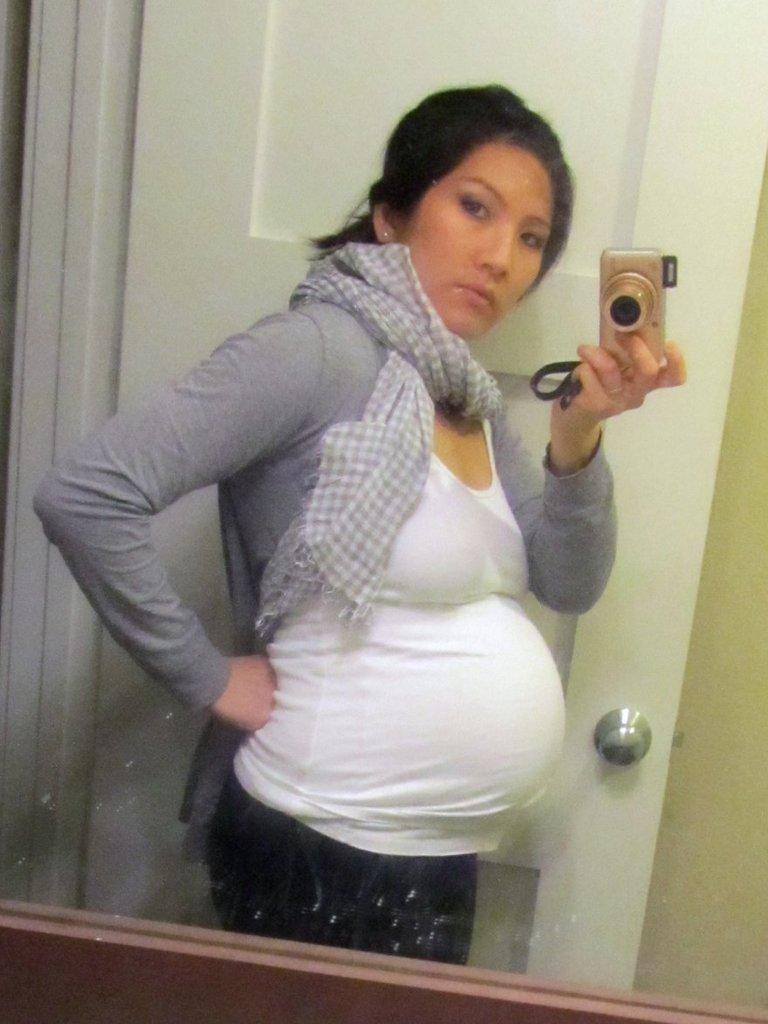What is the main subject of the picture? The main subject of the picture is a pregnant lady. What is the pregnant lady doing in the picture? The pregnant lady is capturing a photo of herself. How is the pregnant lady able to see herself while taking the photo? The pregnant lady is looking into a mirror. What can be seen behind the pregnant lady in the picture? There is a door visible behind the pregnant lady. What channel is the pregnant lady watching on the television in the image? There is no television present in the image, so it is not possible to determine what channel the pregnant lady might be watching. 